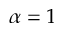Convert formula to latex. <formula><loc_0><loc_0><loc_500><loc_500>\alpha = 1</formula> 